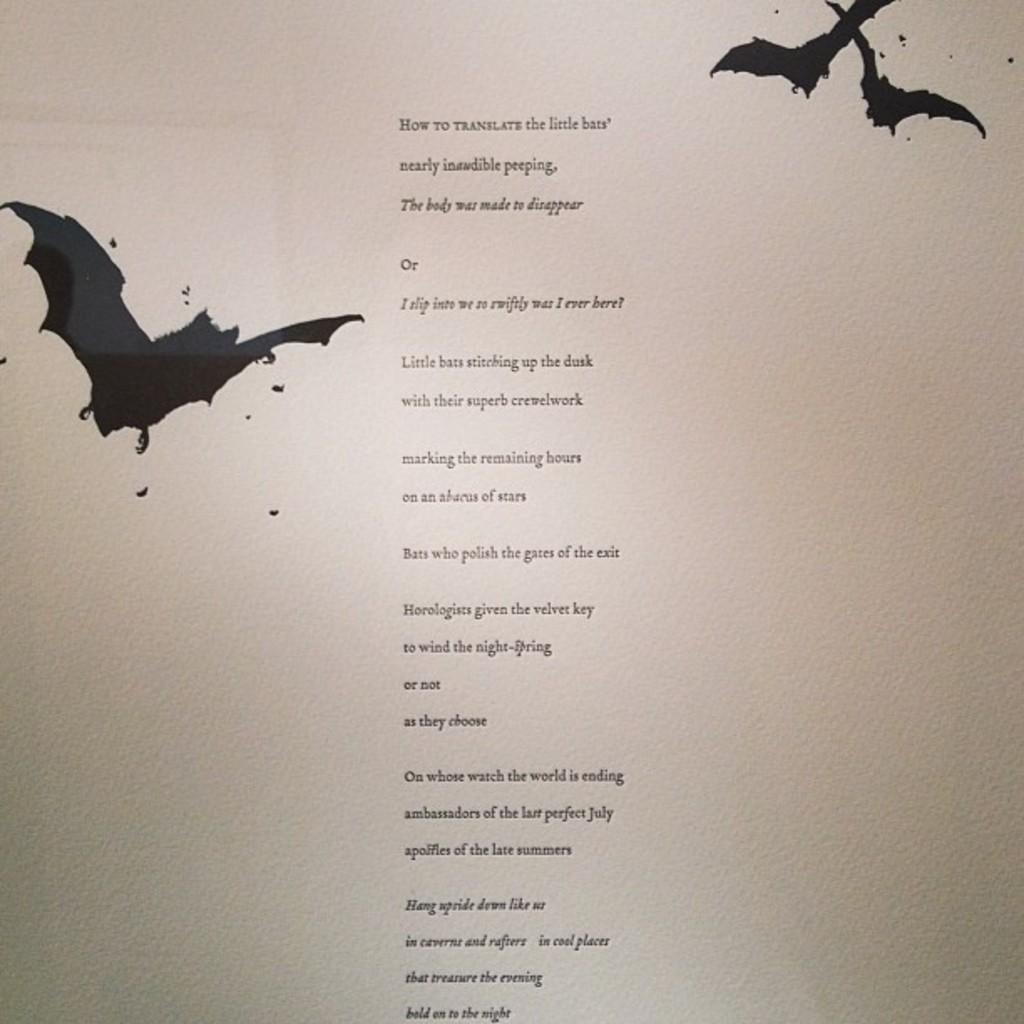What is present on the poster in the image? There is a poster in the image. What can be found on the poster besides the image? The poster contains text. What type of animals are featured on the poster? The poster features birds. What hobbies do the birds on the poster enjoy? There is no information about the birds' hobbies in the image, as it only shows a poster with birds and text. 